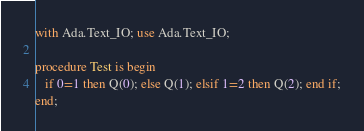<code> <loc_0><loc_0><loc_500><loc_500><_Ada_>with Ada.Text_IO; use Ada.Text_IO;

procedure Test is begin
   if 0=1 then Q(0); else Q(1); elsif 1=2 then Q(2); end if;
end;

</code> 